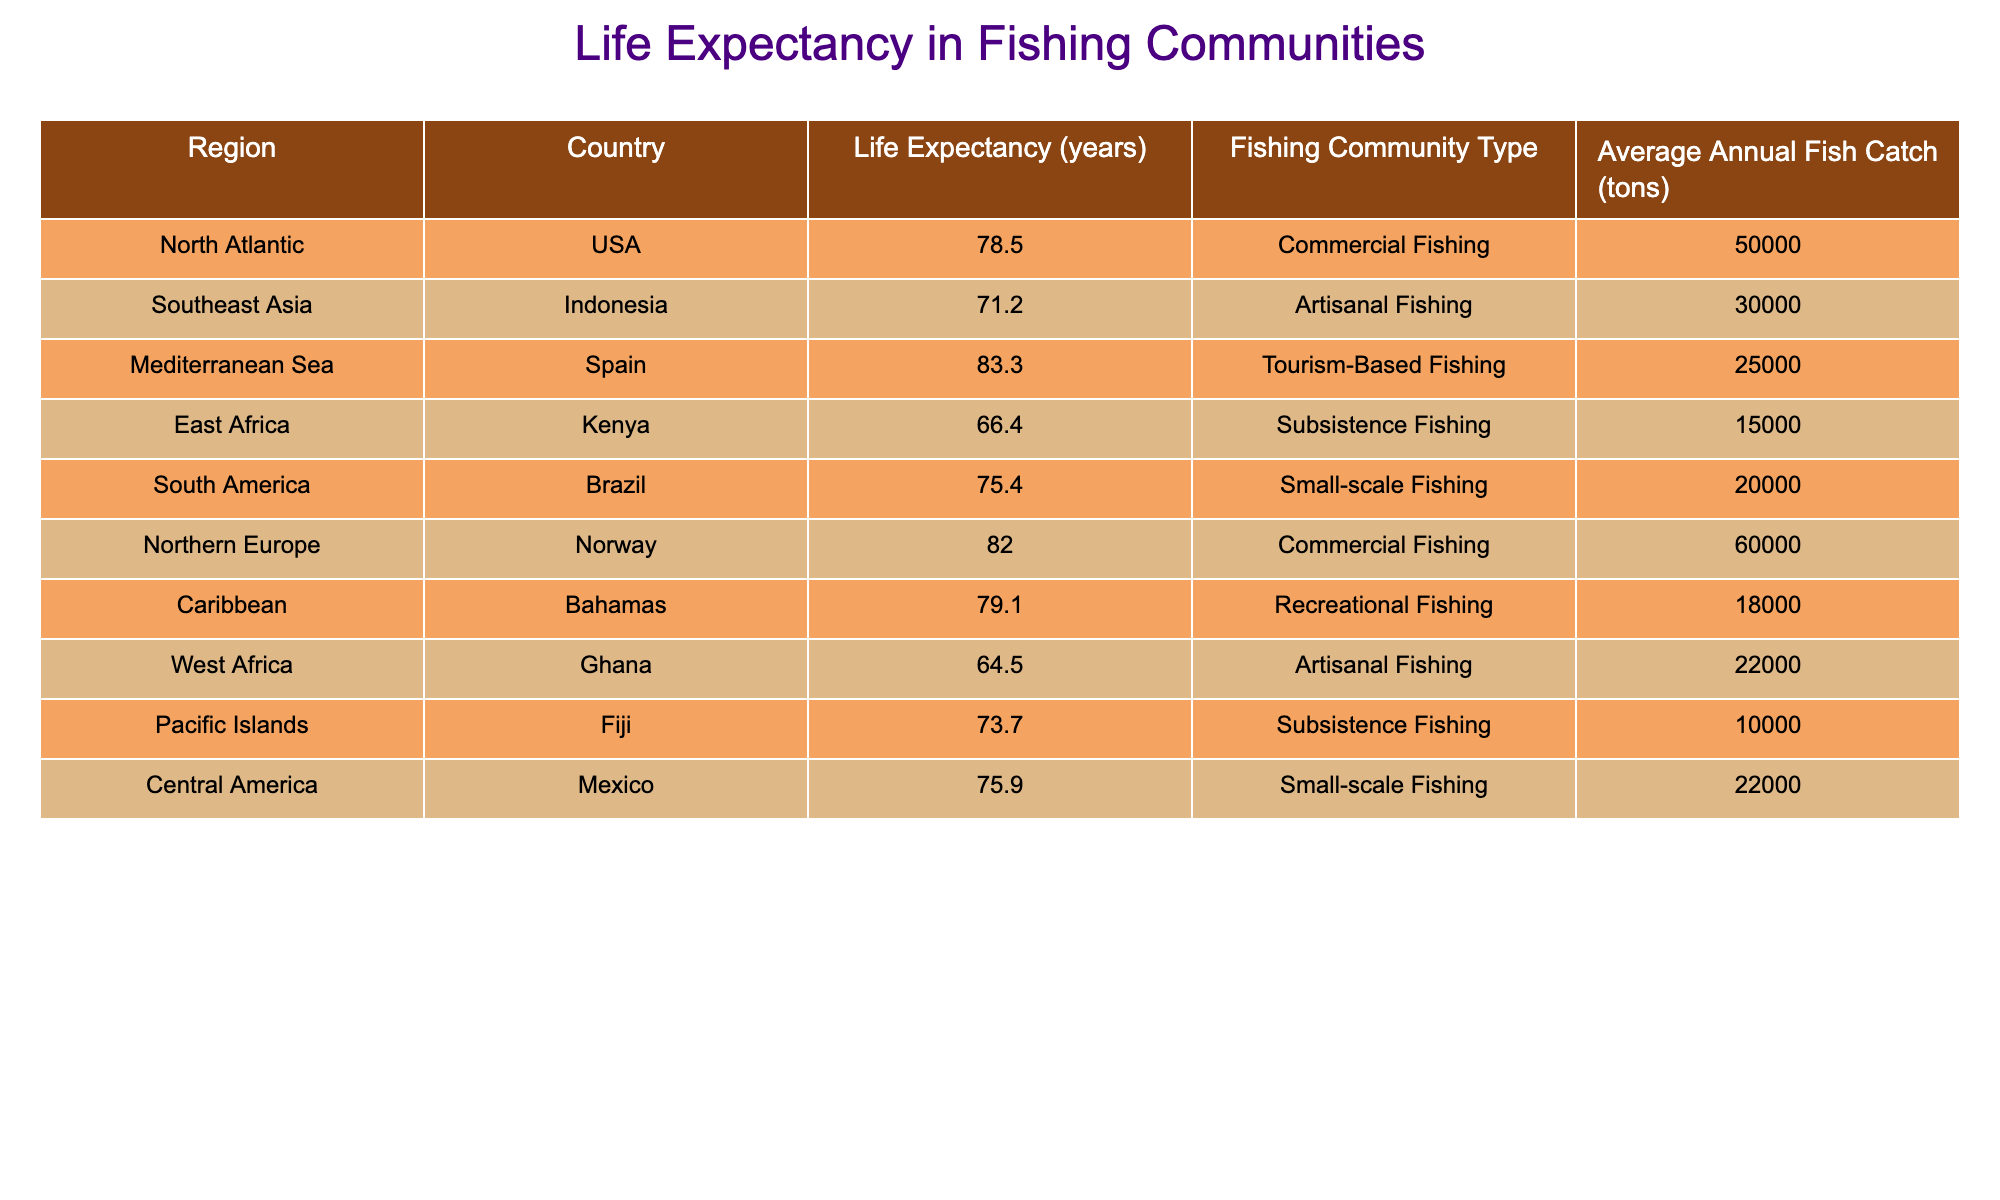What is the life expectancy in the Bahamas? We can directly look at the row for the Bahamas in the table, which shows a life expectancy of 79.1 years.
Answer: 79.1 years Which region has the highest average life expectancy? By comparing the life expectancy values across all regions, we find that the Mediterranean Sea (Spain) has the highest value at 83.3 years.
Answer: Mediterranean Sea How many tons of fish does Norway catch annually compared to Ghana? Norway has an average annual fish catch of 60,000 tons, while Ghana has 22,000 tons. The difference is 60,000 - 22,000 = 38,000 tons, thus Norway catches much more fish than Ghana.
Answer: 38,000 tons Is the life expectancy in Indonesia higher or lower than in Brazil? Indonesia has a life expectancy of 71.2 years, while Brazil has a higher life expectancy of 75.4 years, making Indonesia's life expectancy lower than Brazil's.
Answer: Lower What is the average life expectancy of fishing communities in the Pacific Islands and East Africa combined? The life expectancy in the Pacific Islands (Fiji) is 73.7 years and in East Africa (Kenya) it is 66.4 years. To find the average, we sum them: (73.7 + 66.4) = 140.1 years, and divide by 2 to get 140.1 / 2 = 70.05 years.
Answer: 70.05 years Which fishing community type has the lowest life expectancy and what is that value? By examining the life expectancy, the lowest is found in the East Africa region with a value of 66.4 years, which corresponds to Subsistence Fishing.
Answer: 66.4 years Are there more fishing communities with commercial fishing types or with artisanal fishing types? In the table, we see two community types listed as commercial fishing (USA and Norway) and two as artisanal fishing (Indonesia and Ghana), indicating an equal count of both types, but both types have the same count.
Answer: Equal number What is the total average fish catch (in tons) for all communities listed? We add the average annual fish catches together: 50,000 (USA) + 30,000 (Indonesia) + 25,000 (Spain) + 15,000 (Kenya) + 20,000 (Brazil) + 60,000 (Norway) + 18,000 (Bahamas) + 22,000 (Ghana) + 10,000 (Fiji) + 22,000 (Mexico) = 252,000 tons.
Answer: 252,000 tons 